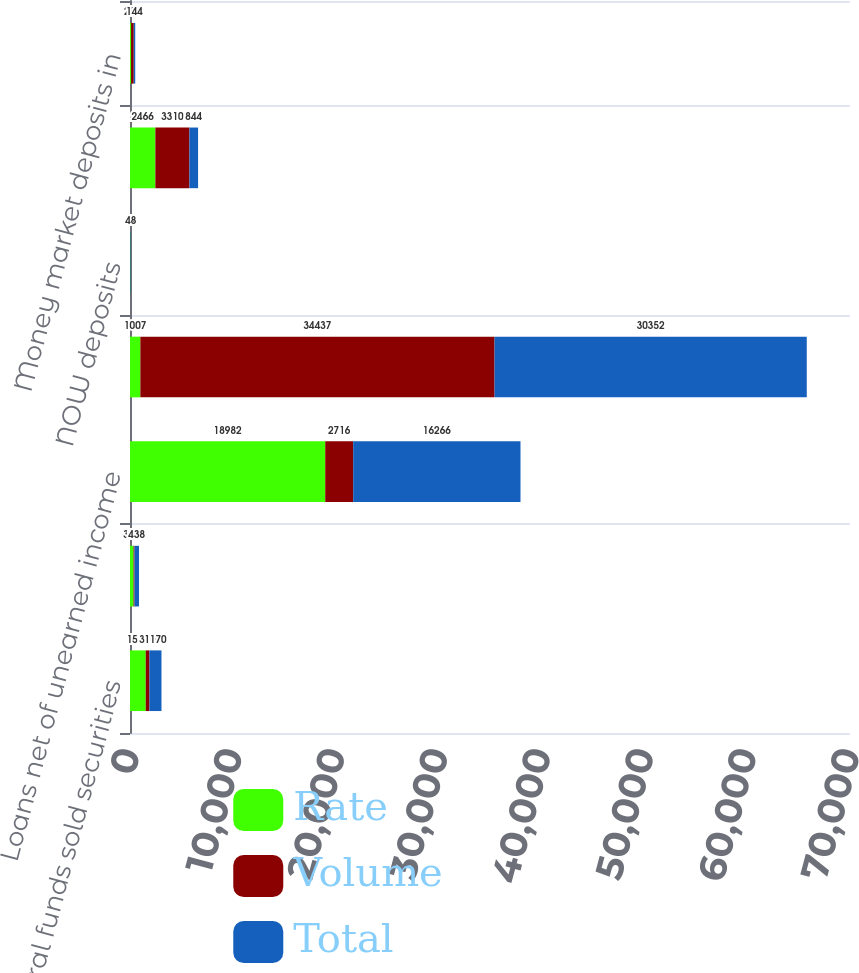Convert chart to OTSL. <chart><loc_0><loc_0><loc_500><loc_500><stacked_bar_chart><ecel><fcel>Federal funds sold securities<fcel>Available-for-sale securities<fcel>Loans net of unearned income<fcel>Increase (decrease) in<fcel>NOW deposits<fcel>Money market deposits<fcel>Money market deposits in<nl><fcel>Rate<fcel>1530<fcel>344<fcel>18982<fcel>1007<fcel>37<fcel>2466<fcel>110<nl><fcel>Volume<fcel>360<fcel>94<fcel>2716<fcel>34437<fcel>11<fcel>3310<fcel>254<nl><fcel>Total<fcel>1170<fcel>438<fcel>16266<fcel>30352<fcel>48<fcel>844<fcel>144<nl></chart> 